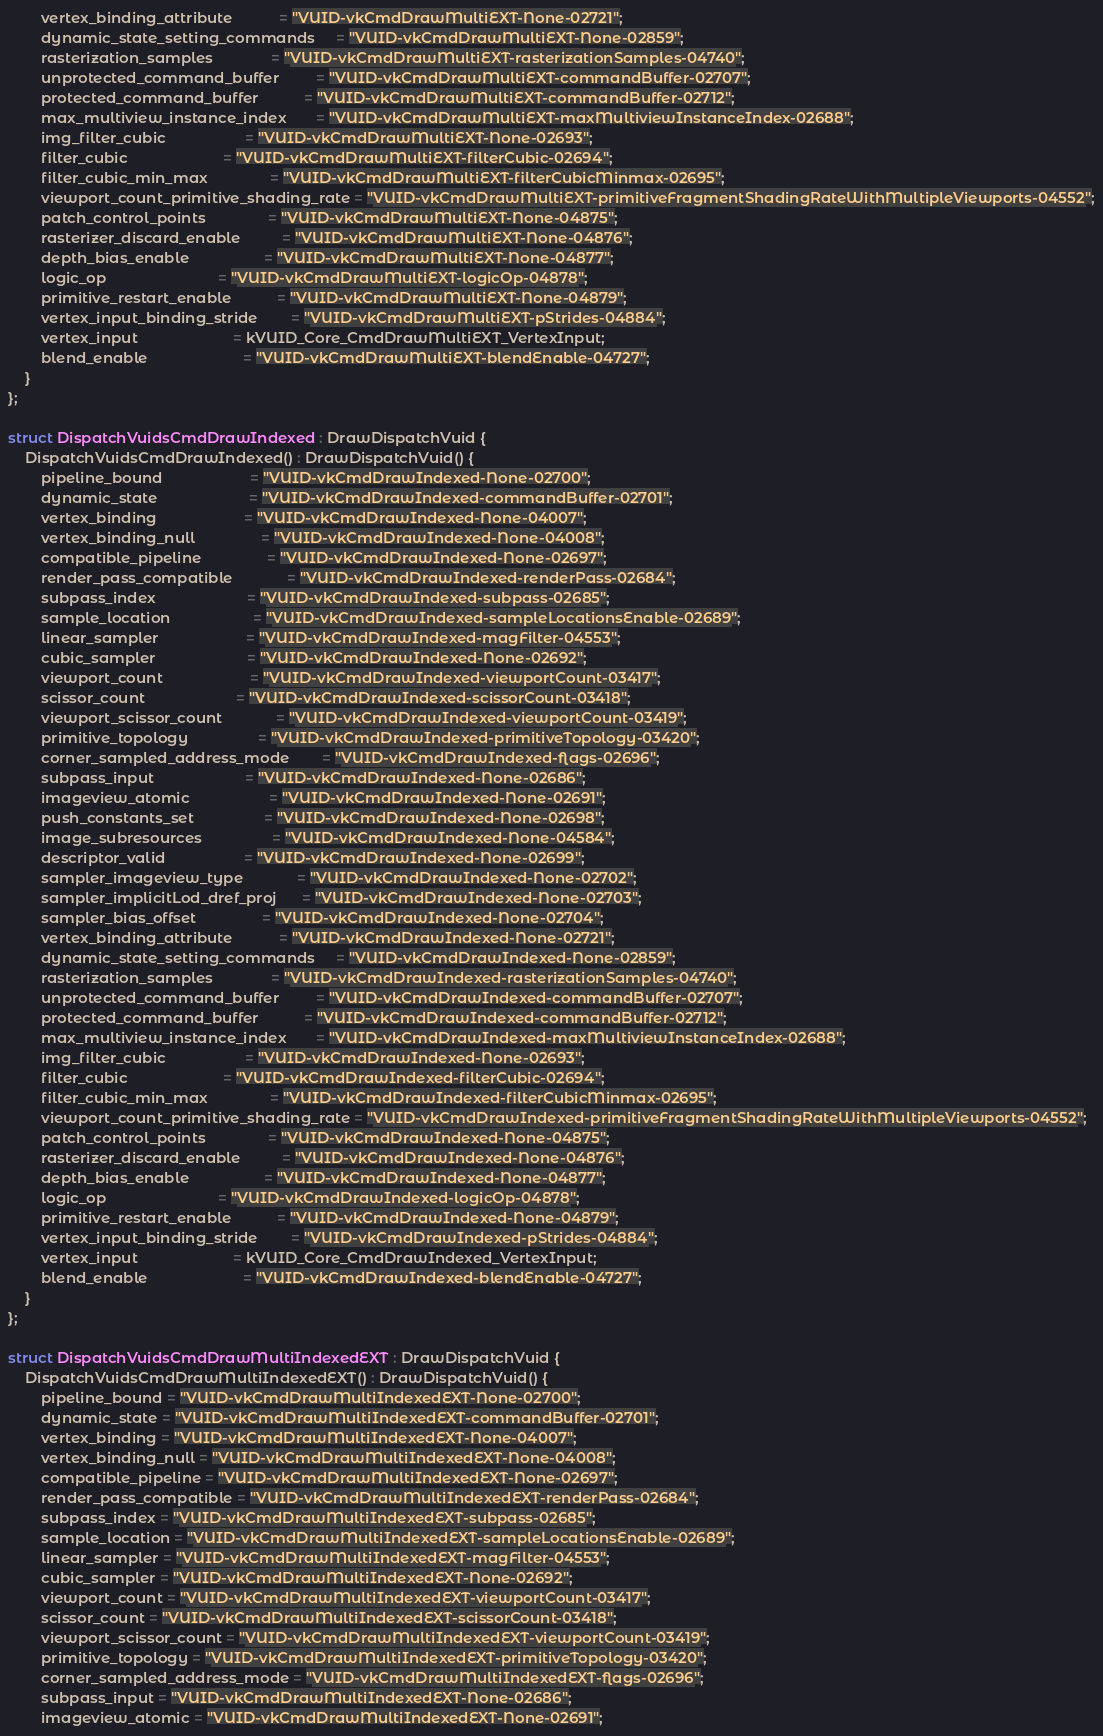Convert code to text. <code><loc_0><loc_0><loc_500><loc_500><_C++_>        vertex_binding_attribute           = "VUID-vkCmdDrawMultiEXT-None-02721";
        dynamic_state_setting_commands     = "VUID-vkCmdDrawMultiEXT-None-02859";
        rasterization_samples              = "VUID-vkCmdDrawMultiEXT-rasterizationSamples-04740";
        unprotected_command_buffer         = "VUID-vkCmdDrawMultiEXT-commandBuffer-02707";
        protected_command_buffer           = "VUID-vkCmdDrawMultiEXT-commandBuffer-02712";
        max_multiview_instance_index       = "VUID-vkCmdDrawMultiEXT-maxMultiviewInstanceIndex-02688";
        img_filter_cubic                   = "VUID-vkCmdDrawMultiEXT-None-02693";
        filter_cubic                       = "VUID-vkCmdDrawMultiEXT-filterCubic-02694";
        filter_cubic_min_max               = "VUID-vkCmdDrawMultiEXT-filterCubicMinmax-02695";
        viewport_count_primitive_shading_rate = "VUID-vkCmdDrawMultiEXT-primitiveFragmentShadingRateWithMultipleViewports-04552";
        patch_control_points               = "VUID-vkCmdDrawMultiEXT-None-04875";
        rasterizer_discard_enable          = "VUID-vkCmdDrawMultiEXT-None-04876";
        depth_bias_enable                  = "VUID-vkCmdDrawMultiEXT-None-04877";
        logic_op                           = "VUID-vkCmdDrawMultiEXT-logicOp-04878";
        primitive_restart_enable           = "VUID-vkCmdDrawMultiEXT-None-04879";
        vertex_input_binding_stride        = "VUID-vkCmdDrawMultiEXT-pStrides-04884";
        vertex_input                       = kVUID_Core_CmdDrawMultiEXT_VertexInput;
        blend_enable                       = "VUID-vkCmdDrawMultiEXT-blendEnable-04727";
    }
};

struct DispatchVuidsCmdDrawIndexed : DrawDispatchVuid {
    DispatchVuidsCmdDrawIndexed() : DrawDispatchVuid() {
        pipeline_bound                     = "VUID-vkCmdDrawIndexed-None-02700";
        dynamic_state                      = "VUID-vkCmdDrawIndexed-commandBuffer-02701";
        vertex_binding                     = "VUID-vkCmdDrawIndexed-None-04007";
        vertex_binding_null                = "VUID-vkCmdDrawIndexed-None-04008";
        compatible_pipeline                = "VUID-vkCmdDrawIndexed-None-02697";
        render_pass_compatible             = "VUID-vkCmdDrawIndexed-renderPass-02684";
        subpass_index                      = "VUID-vkCmdDrawIndexed-subpass-02685";
        sample_location                    = "VUID-vkCmdDrawIndexed-sampleLocationsEnable-02689";
        linear_sampler                     = "VUID-vkCmdDrawIndexed-magFilter-04553";
        cubic_sampler                      = "VUID-vkCmdDrawIndexed-None-02692";
        viewport_count                     = "VUID-vkCmdDrawIndexed-viewportCount-03417";
        scissor_count                      = "VUID-vkCmdDrawIndexed-scissorCount-03418";
        viewport_scissor_count             = "VUID-vkCmdDrawIndexed-viewportCount-03419";
        primitive_topology                 = "VUID-vkCmdDrawIndexed-primitiveTopology-03420";
        corner_sampled_address_mode        = "VUID-vkCmdDrawIndexed-flags-02696";
        subpass_input                      = "VUID-vkCmdDrawIndexed-None-02686";
        imageview_atomic                   = "VUID-vkCmdDrawIndexed-None-02691";
        push_constants_set                 = "VUID-vkCmdDrawIndexed-None-02698";
        image_subresources                 = "VUID-vkCmdDrawIndexed-None-04584";
        descriptor_valid                   = "VUID-vkCmdDrawIndexed-None-02699";
        sampler_imageview_type             = "VUID-vkCmdDrawIndexed-None-02702";
        sampler_implicitLod_dref_proj      = "VUID-vkCmdDrawIndexed-None-02703";
        sampler_bias_offset                = "VUID-vkCmdDrawIndexed-None-02704";
        vertex_binding_attribute           = "VUID-vkCmdDrawIndexed-None-02721";
        dynamic_state_setting_commands     = "VUID-vkCmdDrawIndexed-None-02859";
        rasterization_samples              = "VUID-vkCmdDrawIndexed-rasterizationSamples-04740";
        unprotected_command_buffer         = "VUID-vkCmdDrawIndexed-commandBuffer-02707";
        protected_command_buffer           = "VUID-vkCmdDrawIndexed-commandBuffer-02712";
        max_multiview_instance_index       = "VUID-vkCmdDrawIndexed-maxMultiviewInstanceIndex-02688";
        img_filter_cubic                   = "VUID-vkCmdDrawIndexed-None-02693";
        filter_cubic                       = "VUID-vkCmdDrawIndexed-filterCubic-02694";
        filter_cubic_min_max               = "VUID-vkCmdDrawIndexed-filterCubicMinmax-02695";
        viewport_count_primitive_shading_rate = "VUID-vkCmdDrawIndexed-primitiveFragmentShadingRateWithMultipleViewports-04552";
        patch_control_points               = "VUID-vkCmdDrawIndexed-None-04875";
        rasterizer_discard_enable          = "VUID-vkCmdDrawIndexed-None-04876";
        depth_bias_enable                  = "VUID-vkCmdDrawIndexed-None-04877";
        logic_op                           = "VUID-vkCmdDrawIndexed-logicOp-04878";
        primitive_restart_enable           = "VUID-vkCmdDrawIndexed-None-04879";
        vertex_input_binding_stride        = "VUID-vkCmdDrawIndexed-pStrides-04884";
        vertex_input                       = kVUID_Core_CmdDrawIndexed_VertexInput;
        blend_enable                       = "VUID-vkCmdDrawIndexed-blendEnable-04727";
    }
};

struct DispatchVuidsCmdDrawMultiIndexedEXT : DrawDispatchVuid {
    DispatchVuidsCmdDrawMultiIndexedEXT() : DrawDispatchVuid() {
        pipeline_bound = "VUID-vkCmdDrawMultiIndexedEXT-None-02700";
        dynamic_state = "VUID-vkCmdDrawMultiIndexedEXT-commandBuffer-02701";
        vertex_binding = "VUID-vkCmdDrawMultiIndexedEXT-None-04007";
        vertex_binding_null = "VUID-vkCmdDrawMultiIndexedEXT-None-04008";
        compatible_pipeline = "VUID-vkCmdDrawMultiIndexedEXT-None-02697";
        render_pass_compatible = "VUID-vkCmdDrawMultiIndexedEXT-renderPass-02684";
        subpass_index = "VUID-vkCmdDrawMultiIndexedEXT-subpass-02685";
        sample_location = "VUID-vkCmdDrawMultiIndexedEXT-sampleLocationsEnable-02689";
        linear_sampler = "VUID-vkCmdDrawMultiIndexedEXT-magFilter-04553";
        cubic_sampler = "VUID-vkCmdDrawMultiIndexedEXT-None-02692";
        viewport_count = "VUID-vkCmdDrawMultiIndexedEXT-viewportCount-03417";
        scissor_count = "VUID-vkCmdDrawMultiIndexedEXT-scissorCount-03418";
        viewport_scissor_count = "VUID-vkCmdDrawMultiIndexedEXT-viewportCount-03419";
        primitive_topology = "VUID-vkCmdDrawMultiIndexedEXT-primitiveTopology-03420";
        corner_sampled_address_mode = "VUID-vkCmdDrawMultiIndexedEXT-flags-02696";
        subpass_input = "VUID-vkCmdDrawMultiIndexedEXT-None-02686";
        imageview_atomic = "VUID-vkCmdDrawMultiIndexedEXT-None-02691";</code> 